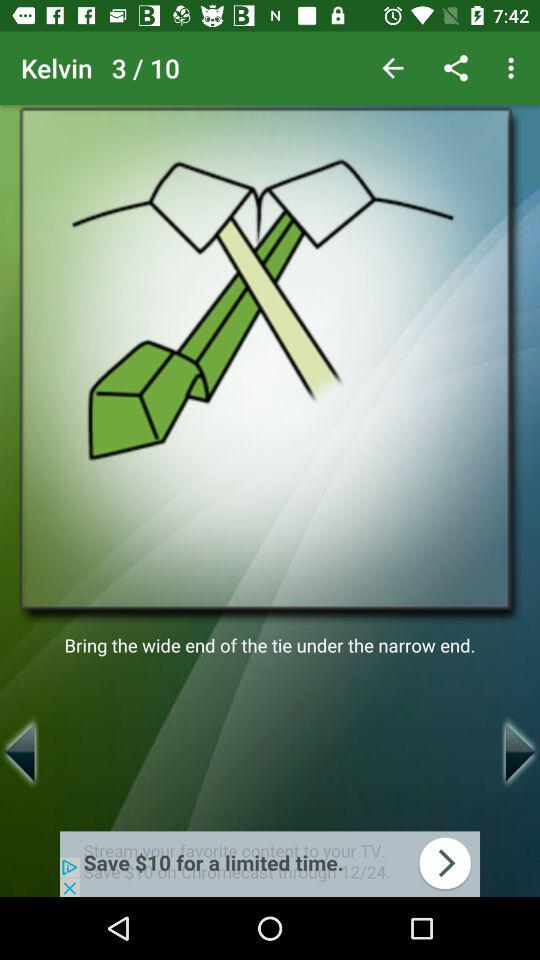How many more steps are there in the tutorial?
Answer the question using a single word or phrase. 7 